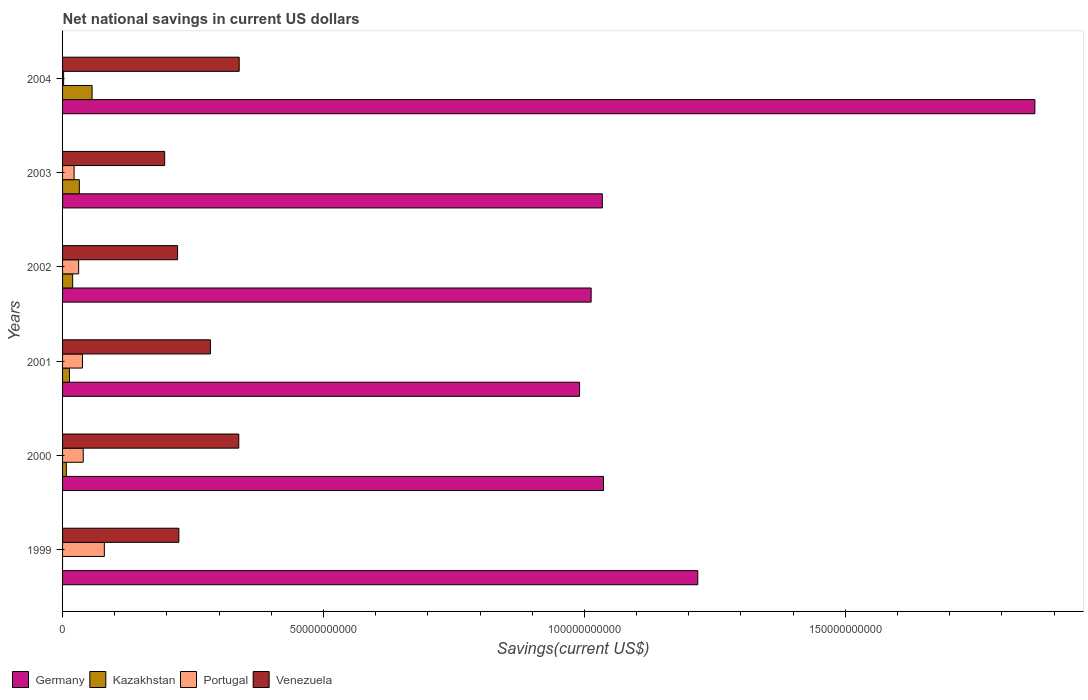Are the number of bars per tick equal to the number of legend labels?
Your response must be concise. No. Are the number of bars on each tick of the Y-axis equal?
Your response must be concise. No. How many bars are there on the 3rd tick from the top?
Your answer should be compact. 4. What is the label of the 1st group of bars from the top?
Make the answer very short. 2004. In how many cases, is the number of bars for a given year not equal to the number of legend labels?
Your answer should be very brief. 1. What is the net national savings in Venezuela in 1999?
Ensure brevity in your answer.  2.23e+1. Across all years, what is the maximum net national savings in Germany?
Your answer should be compact. 1.86e+11. Across all years, what is the minimum net national savings in Germany?
Make the answer very short. 9.91e+1. What is the total net national savings in Venezuela in the graph?
Provide a succinct answer. 1.60e+11. What is the difference between the net national savings in Kazakhstan in 2001 and that in 2003?
Keep it short and to the point. -1.89e+09. What is the difference between the net national savings in Venezuela in 1999 and the net national savings in Germany in 2002?
Ensure brevity in your answer.  -7.90e+1. What is the average net national savings in Kazakhstan per year?
Give a very brief answer. 2.14e+09. In the year 2004, what is the difference between the net national savings in Kazakhstan and net national savings in Venezuela?
Give a very brief answer. -2.82e+1. What is the ratio of the net national savings in Germany in 1999 to that in 2003?
Your answer should be compact. 1.18. What is the difference between the highest and the second highest net national savings in Germany?
Ensure brevity in your answer.  6.46e+1. What is the difference between the highest and the lowest net national savings in Portugal?
Provide a succinct answer. 7.80e+09. Is the sum of the net national savings in Germany in 2000 and 2001 greater than the maximum net national savings in Venezuela across all years?
Offer a terse response. Yes. Is it the case that in every year, the sum of the net national savings in Venezuela and net national savings in Germany is greater than the sum of net national savings in Kazakhstan and net national savings in Portugal?
Your answer should be compact. Yes. How many bars are there?
Keep it short and to the point. 23. Are all the bars in the graph horizontal?
Provide a succinct answer. Yes. How many years are there in the graph?
Ensure brevity in your answer.  6. Where does the legend appear in the graph?
Give a very brief answer. Bottom left. What is the title of the graph?
Make the answer very short. Net national savings in current US dollars. What is the label or title of the X-axis?
Ensure brevity in your answer.  Savings(current US$). What is the label or title of the Y-axis?
Provide a short and direct response. Years. What is the Savings(current US$) of Germany in 1999?
Your answer should be very brief. 1.22e+11. What is the Savings(current US$) in Portugal in 1999?
Your response must be concise. 8.01e+09. What is the Savings(current US$) of Venezuela in 1999?
Offer a very short reply. 2.23e+1. What is the Savings(current US$) in Germany in 2000?
Offer a terse response. 1.04e+11. What is the Savings(current US$) of Kazakhstan in 2000?
Your answer should be compact. 7.24e+08. What is the Savings(current US$) of Portugal in 2000?
Offer a very short reply. 3.96e+09. What is the Savings(current US$) of Venezuela in 2000?
Provide a short and direct response. 3.38e+1. What is the Savings(current US$) of Germany in 2001?
Make the answer very short. 9.91e+1. What is the Savings(current US$) of Kazakhstan in 2001?
Your answer should be compact. 1.33e+09. What is the Savings(current US$) in Portugal in 2001?
Provide a short and direct response. 3.82e+09. What is the Savings(current US$) of Venezuela in 2001?
Offer a very short reply. 2.83e+1. What is the Savings(current US$) of Germany in 2002?
Your response must be concise. 1.01e+11. What is the Savings(current US$) of Kazakhstan in 2002?
Provide a short and direct response. 1.94e+09. What is the Savings(current US$) in Portugal in 2002?
Offer a very short reply. 3.08e+09. What is the Savings(current US$) in Venezuela in 2002?
Your response must be concise. 2.20e+1. What is the Savings(current US$) in Germany in 2003?
Ensure brevity in your answer.  1.03e+11. What is the Savings(current US$) in Kazakhstan in 2003?
Offer a very short reply. 3.22e+09. What is the Savings(current US$) of Portugal in 2003?
Your response must be concise. 2.21e+09. What is the Savings(current US$) of Venezuela in 2003?
Ensure brevity in your answer.  1.96e+1. What is the Savings(current US$) of Germany in 2004?
Offer a terse response. 1.86e+11. What is the Savings(current US$) in Kazakhstan in 2004?
Provide a short and direct response. 5.66e+09. What is the Savings(current US$) in Portugal in 2004?
Offer a very short reply. 2.03e+08. What is the Savings(current US$) in Venezuela in 2004?
Make the answer very short. 3.39e+1. Across all years, what is the maximum Savings(current US$) in Germany?
Offer a very short reply. 1.86e+11. Across all years, what is the maximum Savings(current US$) of Kazakhstan?
Provide a short and direct response. 5.66e+09. Across all years, what is the maximum Savings(current US$) in Portugal?
Provide a succinct answer. 8.01e+09. Across all years, what is the maximum Savings(current US$) in Venezuela?
Keep it short and to the point. 3.39e+1. Across all years, what is the minimum Savings(current US$) in Germany?
Provide a succinct answer. 9.91e+1. Across all years, what is the minimum Savings(current US$) in Portugal?
Offer a terse response. 2.03e+08. Across all years, what is the minimum Savings(current US$) of Venezuela?
Ensure brevity in your answer.  1.96e+1. What is the total Savings(current US$) in Germany in the graph?
Give a very brief answer. 7.16e+11. What is the total Savings(current US$) in Kazakhstan in the graph?
Give a very brief answer. 1.29e+1. What is the total Savings(current US$) of Portugal in the graph?
Provide a short and direct response. 2.13e+1. What is the total Savings(current US$) in Venezuela in the graph?
Your response must be concise. 1.60e+11. What is the difference between the Savings(current US$) in Germany in 1999 and that in 2000?
Your answer should be compact. 1.81e+1. What is the difference between the Savings(current US$) of Portugal in 1999 and that in 2000?
Provide a short and direct response. 4.04e+09. What is the difference between the Savings(current US$) of Venezuela in 1999 and that in 2000?
Keep it short and to the point. -1.15e+1. What is the difference between the Savings(current US$) in Germany in 1999 and that in 2001?
Offer a terse response. 2.27e+1. What is the difference between the Savings(current US$) in Portugal in 1999 and that in 2001?
Offer a very short reply. 4.19e+09. What is the difference between the Savings(current US$) in Venezuela in 1999 and that in 2001?
Your response must be concise. -6.04e+09. What is the difference between the Savings(current US$) of Germany in 1999 and that in 2002?
Your answer should be compact. 2.04e+1. What is the difference between the Savings(current US$) in Portugal in 1999 and that in 2002?
Your response must be concise. 4.92e+09. What is the difference between the Savings(current US$) in Venezuela in 1999 and that in 2002?
Your response must be concise. 2.44e+08. What is the difference between the Savings(current US$) of Germany in 1999 and that in 2003?
Make the answer very short. 1.83e+1. What is the difference between the Savings(current US$) of Portugal in 1999 and that in 2003?
Ensure brevity in your answer.  5.80e+09. What is the difference between the Savings(current US$) in Venezuela in 1999 and that in 2003?
Make the answer very short. 2.72e+09. What is the difference between the Savings(current US$) in Germany in 1999 and that in 2004?
Make the answer very short. -6.46e+1. What is the difference between the Savings(current US$) of Portugal in 1999 and that in 2004?
Your answer should be compact. 7.80e+09. What is the difference between the Savings(current US$) in Venezuela in 1999 and that in 2004?
Your answer should be compact. -1.16e+1. What is the difference between the Savings(current US$) in Germany in 2000 and that in 2001?
Ensure brevity in your answer.  4.59e+09. What is the difference between the Savings(current US$) of Kazakhstan in 2000 and that in 2001?
Your answer should be compact. -6.02e+08. What is the difference between the Savings(current US$) in Portugal in 2000 and that in 2001?
Your answer should be very brief. 1.46e+08. What is the difference between the Savings(current US$) in Venezuela in 2000 and that in 2001?
Provide a succinct answer. 5.44e+09. What is the difference between the Savings(current US$) in Germany in 2000 and that in 2002?
Keep it short and to the point. 2.37e+09. What is the difference between the Savings(current US$) in Kazakhstan in 2000 and that in 2002?
Offer a terse response. -1.21e+09. What is the difference between the Savings(current US$) of Portugal in 2000 and that in 2002?
Give a very brief answer. 8.78e+08. What is the difference between the Savings(current US$) of Venezuela in 2000 and that in 2002?
Your response must be concise. 1.17e+1. What is the difference between the Savings(current US$) in Germany in 2000 and that in 2003?
Keep it short and to the point. 2.28e+08. What is the difference between the Savings(current US$) of Kazakhstan in 2000 and that in 2003?
Your answer should be very brief. -2.49e+09. What is the difference between the Savings(current US$) in Portugal in 2000 and that in 2003?
Offer a terse response. 1.75e+09. What is the difference between the Savings(current US$) of Venezuela in 2000 and that in 2003?
Your answer should be very brief. 1.42e+1. What is the difference between the Savings(current US$) of Germany in 2000 and that in 2004?
Ensure brevity in your answer.  -8.27e+1. What is the difference between the Savings(current US$) in Kazakhstan in 2000 and that in 2004?
Ensure brevity in your answer.  -4.94e+09. What is the difference between the Savings(current US$) of Portugal in 2000 and that in 2004?
Offer a terse response. 3.76e+09. What is the difference between the Savings(current US$) in Venezuela in 2000 and that in 2004?
Provide a succinct answer. -8.18e+07. What is the difference between the Savings(current US$) in Germany in 2001 and that in 2002?
Make the answer very short. -2.22e+09. What is the difference between the Savings(current US$) of Kazakhstan in 2001 and that in 2002?
Offer a terse response. -6.10e+08. What is the difference between the Savings(current US$) of Portugal in 2001 and that in 2002?
Keep it short and to the point. 7.32e+08. What is the difference between the Savings(current US$) of Venezuela in 2001 and that in 2002?
Your answer should be compact. 6.29e+09. What is the difference between the Savings(current US$) of Germany in 2001 and that in 2003?
Your answer should be compact. -4.36e+09. What is the difference between the Savings(current US$) in Kazakhstan in 2001 and that in 2003?
Keep it short and to the point. -1.89e+09. What is the difference between the Savings(current US$) of Portugal in 2001 and that in 2003?
Your answer should be compact. 1.61e+09. What is the difference between the Savings(current US$) of Venezuela in 2001 and that in 2003?
Ensure brevity in your answer.  8.77e+09. What is the difference between the Savings(current US$) in Germany in 2001 and that in 2004?
Your response must be concise. -8.73e+1. What is the difference between the Savings(current US$) in Kazakhstan in 2001 and that in 2004?
Give a very brief answer. -4.33e+09. What is the difference between the Savings(current US$) of Portugal in 2001 and that in 2004?
Give a very brief answer. 3.61e+09. What is the difference between the Savings(current US$) of Venezuela in 2001 and that in 2004?
Keep it short and to the point. -5.52e+09. What is the difference between the Savings(current US$) in Germany in 2002 and that in 2003?
Your answer should be very brief. -2.14e+09. What is the difference between the Savings(current US$) in Kazakhstan in 2002 and that in 2003?
Ensure brevity in your answer.  -1.28e+09. What is the difference between the Savings(current US$) of Portugal in 2002 and that in 2003?
Make the answer very short. 8.75e+08. What is the difference between the Savings(current US$) in Venezuela in 2002 and that in 2003?
Ensure brevity in your answer.  2.48e+09. What is the difference between the Savings(current US$) in Germany in 2002 and that in 2004?
Offer a very short reply. -8.50e+1. What is the difference between the Savings(current US$) of Kazakhstan in 2002 and that in 2004?
Offer a very short reply. -3.72e+09. What is the difference between the Savings(current US$) in Portugal in 2002 and that in 2004?
Your answer should be compact. 2.88e+09. What is the difference between the Savings(current US$) of Venezuela in 2002 and that in 2004?
Make the answer very short. -1.18e+1. What is the difference between the Savings(current US$) in Germany in 2003 and that in 2004?
Make the answer very short. -8.29e+1. What is the difference between the Savings(current US$) in Kazakhstan in 2003 and that in 2004?
Make the answer very short. -2.44e+09. What is the difference between the Savings(current US$) of Portugal in 2003 and that in 2004?
Provide a short and direct response. 2.01e+09. What is the difference between the Savings(current US$) in Venezuela in 2003 and that in 2004?
Offer a terse response. -1.43e+1. What is the difference between the Savings(current US$) of Germany in 1999 and the Savings(current US$) of Kazakhstan in 2000?
Your response must be concise. 1.21e+11. What is the difference between the Savings(current US$) of Germany in 1999 and the Savings(current US$) of Portugal in 2000?
Your response must be concise. 1.18e+11. What is the difference between the Savings(current US$) in Germany in 1999 and the Savings(current US$) in Venezuela in 2000?
Your answer should be compact. 8.80e+1. What is the difference between the Savings(current US$) in Portugal in 1999 and the Savings(current US$) in Venezuela in 2000?
Your answer should be compact. -2.58e+1. What is the difference between the Savings(current US$) of Germany in 1999 and the Savings(current US$) of Kazakhstan in 2001?
Give a very brief answer. 1.20e+11. What is the difference between the Savings(current US$) in Germany in 1999 and the Savings(current US$) in Portugal in 2001?
Offer a very short reply. 1.18e+11. What is the difference between the Savings(current US$) in Germany in 1999 and the Savings(current US$) in Venezuela in 2001?
Keep it short and to the point. 9.34e+1. What is the difference between the Savings(current US$) of Portugal in 1999 and the Savings(current US$) of Venezuela in 2001?
Your answer should be compact. -2.03e+1. What is the difference between the Savings(current US$) of Germany in 1999 and the Savings(current US$) of Kazakhstan in 2002?
Provide a succinct answer. 1.20e+11. What is the difference between the Savings(current US$) in Germany in 1999 and the Savings(current US$) in Portugal in 2002?
Offer a terse response. 1.19e+11. What is the difference between the Savings(current US$) in Germany in 1999 and the Savings(current US$) in Venezuela in 2002?
Provide a succinct answer. 9.97e+1. What is the difference between the Savings(current US$) in Portugal in 1999 and the Savings(current US$) in Venezuela in 2002?
Your answer should be very brief. -1.40e+1. What is the difference between the Savings(current US$) in Germany in 1999 and the Savings(current US$) in Kazakhstan in 2003?
Provide a succinct answer. 1.19e+11. What is the difference between the Savings(current US$) of Germany in 1999 and the Savings(current US$) of Portugal in 2003?
Keep it short and to the point. 1.20e+11. What is the difference between the Savings(current US$) of Germany in 1999 and the Savings(current US$) of Venezuela in 2003?
Give a very brief answer. 1.02e+11. What is the difference between the Savings(current US$) of Portugal in 1999 and the Savings(current US$) of Venezuela in 2003?
Give a very brief answer. -1.16e+1. What is the difference between the Savings(current US$) of Germany in 1999 and the Savings(current US$) of Kazakhstan in 2004?
Your answer should be compact. 1.16e+11. What is the difference between the Savings(current US$) of Germany in 1999 and the Savings(current US$) of Portugal in 2004?
Keep it short and to the point. 1.22e+11. What is the difference between the Savings(current US$) in Germany in 1999 and the Savings(current US$) in Venezuela in 2004?
Make the answer very short. 8.79e+1. What is the difference between the Savings(current US$) of Portugal in 1999 and the Savings(current US$) of Venezuela in 2004?
Keep it short and to the point. -2.58e+1. What is the difference between the Savings(current US$) of Germany in 2000 and the Savings(current US$) of Kazakhstan in 2001?
Offer a terse response. 1.02e+11. What is the difference between the Savings(current US$) of Germany in 2000 and the Savings(current US$) of Portugal in 2001?
Offer a terse response. 9.98e+1. What is the difference between the Savings(current US$) of Germany in 2000 and the Savings(current US$) of Venezuela in 2001?
Provide a short and direct response. 7.53e+1. What is the difference between the Savings(current US$) of Kazakhstan in 2000 and the Savings(current US$) of Portugal in 2001?
Your answer should be very brief. -3.09e+09. What is the difference between the Savings(current US$) in Kazakhstan in 2000 and the Savings(current US$) in Venezuela in 2001?
Provide a short and direct response. -2.76e+1. What is the difference between the Savings(current US$) in Portugal in 2000 and the Savings(current US$) in Venezuela in 2001?
Your answer should be compact. -2.44e+1. What is the difference between the Savings(current US$) in Germany in 2000 and the Savings(current US$) in Kazakhstan in 2002?
Ensure brevity in your answer.  1.02e+11. What is the difference between the Savings(current US$) of Germany in 2000 and the Savings(current US$) of Portugal in 2002?
Make the answer very short. 1.01e+11. What is the difference between the Savings(current US$) in Germany in 2000 and the Savings(current US$) in Venezuela in 2002?
Your response must be concise. 8.16e+1. What is the difference between the Savings(current US$) of Kazakhstan in 2000 and the Savings(current US$) of Portugal in 2002?
Your answer should be very brief. -2.36e+09. What is the difference between the Savings(current US$) in Kazakhstan in 2000 and the Savings(current US$) in Venezuela in 2002?
Offer a very short reply. -2.13e+1. What is the difference between the Savings(current US$) of Portugal in 2000 and the Savings(current US$) of Venezuela in 2002?
Provide a short and direct response. -1.81e+1. What is the difference between the Savings(current US$) of Germany in 2000 and the Savings(current US$) of Kazakhstan in 2003?
Give a very brief answer. 1.00e+11. What is the difference between the Savings(current US$) of Germany in 2000 and the Savings(current US$) of Portugal in 2003?
Make the answer very short. 1.01e+11. What is the difference between the Savings(current US$) in Germany in 2000 and the Savings(current US$) in Venezuela in 2003?
Make the answer very short. 8.41e+1. What is the difference between the Savings(current US$) in Kazakhstan in 2000 and the Savings(current US$) in Portugal in 2003?
Provide a succinct answer. -1.49e+09. What is the difference between the Savings(current US$) of Kazakhstan in 2000 and the Savings(current US$) of Venezuela in 2003?
Provide a short and direct response. -1.88e+1. What is the difference between the Savings(current US$) in Portugal in 2000 and the Savings(current US$) in Venezuela in 2003?
Ensure brevity in your answer.  -1.56e+1. What is the difference between the Savings(current US$) of Germany in 2000 and the Savings(current US$) of Kazakhstan in 2004?
Your answer should be very brief. 9.80e+1. What is the difference between the Savings(current US$) of Germany in 2000 and the Savings(current US$) of Portugal in 2004?
Offer a terse response. 1.03e+11. What is the difference between the Savings(current US$) in Germany in 2000 and the Savings(current US$) in Venezuela in 2004?
Provide a succinct answer. 6.98e+1. What is the difference between the Savings(current US$) in Kazakhstan in 2000 and the Savings(current US$) in Portugal in 2004?
Provide a succinct answer. 5.20e+08. What is the difference between the Savings(current US$) of Kazakhstan in 2000 and the Savings(current US$) of Venezuela in 2004?
Offer a very short reply. -3.31e+1. What is the difference between the Savings(current US$) in Portugal in 2000 and the Savings(current US$) in Venezuela in 2004?
Offer a very short reply. -2.99e+1. What is the difference between the Savings(current US$) of Germany in 2001 and the Savings(current US$) of Kazakhstan in 2002?
Give a very brief answer. 9.71e+1. What is the difference between the Savings(current US$) in Germany in 2001 and the Savings(current US$) in Portugal in 2002?
Provide a short and direct response. 9.60e+1. What is the difference between the Savings(current US$) of Germany in 2001 and the Savings(current US$) of Venezuela in 2002?
Offer a very short reply. 7.70e+1. What is the difference between the Savings(current US$) in Kazakhstan in 2001 and the Savings(current US$) in Portugal in 2002?
Make the answer very short. -1.76e+09. What is the difference between the Savings(current US$) of Kazakhstan in 2001 and the Savings(current US$) of Venezuela in 2002?
Ensure brevity in your answer.  -2.07e+1. What is the difference between the Savings(current US$) of Portugal in 2001 and the Savings(current US$) of Venezuela in 2002?
Provide a short and direct response. -1.82e+1. What is the difference between the Savings(current US$) in Germany in 2001 and the Savings(current US$) in Kazakhstan in 2003?
Your answer should be very brief. 9.59e+1. What is the difference between the Savings(current US$) of Germany in 2001 and the Savings(current US$) of Portugal in 2003?
Offer a very short reply. 9.69e+1. What is the difference between the Savings(current US$) of Germany in 2001 and the Savings(current US$) of Venezuela in 2003?
Ensure brevity in your answer.  7.95e+1. What is the difference between the Savings(current US$) of Kazakhstan in 2001 and the Savings(current US$) of Portugal in 2003?
Provide a succinct answer. -8.84e+08. What is the difference between the Savings(current US$) in Kazakhstan in 2001 and the Savings(current US$) in Venezuela in 2003?
Your answer should be compact. -1.82e+1. What is the difference between the Savings(current US$) of Portugal in 2001 and the Savings(current US$) of Venezuela in 2003?
Offer a very short reply. -1.57e+1. What is the difference between the Savings(current US$) in Germany in 2001 and the Savings(current US$) in Kazakhstan in 2004?
Your answer should be very brief. 9.34e+1. What is the difference between the Savings(current US$) in Germany in 2001 and the Savings(current US$) in Portugal in 2004?
Your answer should be very brief. 9.89e+1. What is the difference between the Savings(current US$) of Germany in 2001 and the Savings(current US$) of Venezuela in 2004?
Offer a very short reply. 6.52e+1. What is the difference between the Savings(current US$) of Kazakhstan in 2001 and the Savings(current US$) of Portugal in 2004?
Provide a short and direct response. 1.12e+09. What is the difference between the Savings(current US$) in Kazakhstan in 2001 and the Savings(current US$) in Venezuela in 2004?
Offer a terse response. -3.25e+1. What is the difference between the Savings(current US$) of Portugal in 2001 and the Savings(current US$) of Venezuela in 2004?
Ensure brevity in your answer.  -3.00e+1. What is the difference between the Savings(current US$) in Germany in 2002 and the Savings(current US$) in Kazakhstan in 2003?
Keep it short and to the point. 9.81e+1. What is the difference between the Savings(current US$) of Germany in 2002 and the Savings(current US$) of Portugal in 2003?
Offer a terse response. 9.91e+1. What is the difference between the Savings(current US$) in Germany in 2002 and the Savings(current US$) in Venezuela in 2003?
Make the answer very short. 8.17e+1. What is the difference between the Savings(current US$) of Kazakhstan in 2002 and the Savings(current US$) of Portugal in 2003?
Make the answer very short. -2.74e+08. What is the difference between the Savings(current US$) in Kazakhstan in 2002 and the Savings(current US$) in Venezuela in 2003?
Offer a very short reply. -1.76e+1. What is the difference between the Savings(current US$) in Portugal in 2002 and the Savings(current US$) in Venezuela in 2003?
Provide a short and direct response. -1.65e+1. What is the difference between the Savings(current US$) in Germany in 2002 and the Savings(current US$) in Kazakhstan in 2004?
Your answer should be very brief. 9.56e+1. What is the difference between the Savings(current US$) of Germany in 2002 and the Savings(current US$) of Portugal in 2004?
Keep it short and to the point. 1.01e+11. What is the difference between the Savings(current US$) in Germany in 2002 and the Savings(current US$) in Venezuela in 2004?
Provide a short and direct response. 6.74e+1. What is the difference between the Savings(current US$) of Kazakhstan in 2002 and the Savings(current US$) of Portugal in 2004?
Provide a short and direct response. 1.73e+09. What is the difference between the Savings(current US$) in Kazakhstan in 2002 and the Savings(current US$) in Venezuela in 2004?
Provide a succinct answer. -3.19e+1. What is the difference between the Savings(current US$) of Portugal in 2002 and the Savings(current US$) of Venezuela in 2004?
Give a very brief answer. -3.08e+1. What is the difference between the Savings(current US$) of Germany in 2003 and the Savings(current US$) of Kazakhstan in 2004?
Offer a very short reply. 9.78e+1. What is the difference between the Savings(current US$) of Germany in 2003 and the Savings(current US$) of Portugal in 2004?
Give a very brief answer. 1.03e+11. What is the difference between the Savings(current US$) of Germany in 2003 and the Savings(current US$) of Venezuela in 2004?
Offer a terse response. 6.96e+1. What is the difference between the Savings(current US$) of Kazakhstan in 2003 and the Savings(current US$) of Portugal in 2004?
Offer a terse response. 3.01e+09. What is the difference between the Savings(current US$) in Kazakhstan in 2003 and the Savings(current US$) in Venezuela in 2004?
Make the answer very short. -3.06e+1. What is the difference between the Savings(current US$) in Portugal in 2003 and the Savings(current US$) in Venezuela in 2004?
Provide a succinct answer. -3.16e+1. What is the average Savings(current US$) in Germany per year?
Your answer should be compact. 1.19e+11. What is the average Savings(current US$) of Kazakhstan per year?
Your response must be concise. 2.14e+09. What is the average Savings(current US$) of Portugal per year?
Provide a succinct answer. 3.55e+09. What is the average Savings(current US$) in Venezuela per year?
Your answer should be very brief. 2.66e+1. In the year 1999, what is the difference between the Savings(current US$) in Germany and Savings(current US$) in Portugal?
Keep it short and to the point. 1.14e+11. In the year 1999, what is the difference between the Savings(current US$) in Germany and Savings(current US$) in Venezuela?
Keep it short and to the point. 9.94e+1. In the year 1999, what is the difference between the Savings(current US$) of Portugal and Savings(current US$) of Venezuela?
Your response must be concise. -1.43e+1. In the year 2000, what is the difference between the Savings(current US$) in Germany and Savings(current US$) in Kazakhstan?
Offer a terse response. 1.03e+11. In the year 2000, what is the difference between the Savings(current US$) in Germany and Savings(current US$) in Portugal?
Your answer should be compact. 9.97e+1. In the year 2000, what is the difference between the Savings(current US$) in Germany and Savings(current US$) in Venezuela?
Provide a succinct answer. 6.99e+1. In the year 2000, what is the difference between the Savings(current US$) of Kazakhstan and Savings(current US$) of Portugal?
Your response must be concise. -3.24e+09. In the year 2000, what is the difference between the Savings(current US$) of Kazakhstan and Savings(current US$) of Venezuela?
Your response must be concise. -3.30e+1. In the year 2000, what is the difference between the Savings(current US$) in Portugal and Savings(current US$) in Venezuela?
Give a very brief answer. -2.98e+1. In the year 2001, what is the difference between the Savings(current US$) in Germany and Savings(current US$) in Kazakhstan?
Your answer should be compact. 9.77e+1. In the year 2001, what is the difference between the Savings(current US$) of Germany and Savings(current US$) of Portugal?
Provide a succinct answer. 9.53e+1. In the year 2001, what is the difference between the Savings(current US$) in Germany and Savings(current US$) in Venezuela?
Offer a terse response. 7.07e+1. In the year 2001, what is the difference between the Savings(current US$) in Kazakhstan and Savings(current US$) in Portugal?
Your answer should be very brief. -2.49e+09. In the year 2001, what is the difference between the Savings(current US$) in Kazakhstan and Savings(current US$) in Venezuela?
Your answer should be compact. -2.70e+1. In the year 2001, what is the difference between the Savings(current US$) in Portugal and Savings(current US$) in Venezuela?
Ensure brevity in your answer.  -2.45e+1. In the year 2002, what is the difference between the Savings(current US$) of Germany and Savings(current US$) of Kazakhstan?
Offer a very short reply. 9.94e+1. In the year 2002, what is the difference between the Savings(current US$) in Germany and Savings(current US$) in Portugal?
Offer a terse response. 9.82e+1. In the year 2002, what is the difference between the Savings(current US$) in Germany and Savings(current US$) in Venezuela?
Your answer should be compact. 7.93e+1. In the year 2002, what is the difference between the Savings(current US$) in Kazakhstan and Savings(current US$) in Portugal?
Keep it short and to the point. -1.15e+09. In the year 2002, what is the difference between the Savings(current US$) in Kazakhstan and Savings(current US$) in Venezuela?
Give a very brief answer. -2.01e+1. In the year 2002, what is the difference between the Savings(current US$) of Portugal and Savings(current US$) of Venezuela?
Offer a very short reply. -1.90e+1. In the year 2003, what is the difference between the Savings(current US$) in Germany and Savings(current US$) in Kazakhstan?
Ensure brevity in your answer.  1.00e+11. In the year 2003, what is the difference between the Savings(current US$) in Germany and Savings(current US$) in Portugal?
Your answer should be very brief. 1.01e+11. In the year 2003, what is the difference between the Savings(current US$) in Germany and Savings(current US$) in Venezuela?
Your answer should be very brief. 8.39e+1. In the year 2003, what is the difference between the Savings(current US$) in Kazakhstan and Savings(current US$) in Portugal?
Provide a short and direct response. 1.01e+09. In the year 2003, what is the difference between the Savings(current US$) in Kazakhstan and Savings(current US$) in Venezuela?
Offer a very short reply. -1.63e+1. In the year 2003, what is the difference between the Savings(current US$) of Portugal and Savings(current US$) of Venezuela?
Provide a short and direct response. -1.74e+1. In the year 2004, what is the difference between the Savings(current US$) in Germany and Savings(current US$) in Kazakhstan?
Keep it short and to the point. 1.81e+11. In the year 2004, what is the difference between the Savings(current US$) of Germany and Savings(current US$) of Portugal?
Provide a succinct answer. 1.86e+11. In the year 2004, what is the difference between the Savings(current US$) in Germany and Savings(current US$) in Venezuela?
Make the answer very short. 1.52e+11. In the year 2004, what is the difference between the Savings(current US$) of Kazakhstan and Savings(current US$) of Portugal?
Make the answer very short. 5.46e+09. In the year 2004, what is the difference between the Savings(current US$) in Kazakhstan and Savings(current US$) in Venezuela?
Make the answer very short. -2.82e+1. In the year 2004, what is the difference between the Savings(current US$) of Portugal and Savings(current US$) of Venezuela?
Ensure brevity in your answer.  -3.36e+1. What is the ratio of the Savings(current US$) of Germany in 1999 to that in 2000?
Offer a very short reply. 1.17. What is the ratio of the Savings(current US$) in Portugal in 1999 to that in 2000?
Your answer should be very brief. 2.02. What is the ratio of the Savings(current US$) of Venezuela in 1999 to that in 2000?
Your answer should be very brief. 0.66. What is the ratio of the Savings(current US$) in Germany in 1999 to that in 2001?
Provide a succinct answer. 1.23. What is the ratio of the Savings(current US$) in Portugal in 1999 to that in 2001?
Provide a succinct answer. 2.1. What is the ratio of the Savings(current US$) in Venezuela in 1999 to that in 2001?
Your response must be concise. 0.79. What is the ratio of the Savings(current US$) in Germany in 1999 to that in 2002?
Make the answer very short. 1.2. What is the ratio of the Savings(current US$) in Portugal in 1999 to that in 2002?
Ensure brevity in your answer.  2.6. What is the ratio of the Savings(current US$) in Venezuela in 1999 to that in 2002?
Offer a very short reply. 1.01. What is the ratio of the Savings(current US$) of Germany in 1999 to that in 2003?
Provide a short and direct response. 1.18. What is the ratio of the Savings(current US$) of Portugal in 1999 to that in 2003?
Ensure brevity in your answer.  3.62. What is the ratio of the Savings(current US$) of Venezuela in 1999 to that in 2003?
Your answer should be very brief. 1.14. What is the ratio of the Savings(current US$) in Germany in 1999 to that in 2004?
Make the answer very short. 0.65. What is the ratio of the Savings(current US$) of Portugal in 1999 to that in 2004?
Offer a very short reply. 39.36. What is the ratio of the Savings(current US$) in Venezuela in 1999 to that in 2004?
Make the answer very short. 0.66. What is the ratio of the Savings(current US$) of Germany in 2000 to that in 2001?
Your answer should be compact. 1.05. What is the ratio of the Savings(current US$) in Kazakhstan in 2000 to that in 2001?
Offer a terse response. 0.55. What is the ratio of the Savings(current US$) of Portugal in 2000 to that in 2001?
Make the answer very short. 1.04. What is the ratio of the Savings(current US$) in Venezuela in 2000 to that in 2001?
Your response must be concise. 1.19. What is the ratio of the Savings(current US$) in Germany in 2000 to that in 2002?
Keep it short and to the point. 1.02. What is the ratio of the Savings(current US$) of Kazakhstan in 2000 to that in 2002?
Your answer should be very brief. 0.37. What is the ratio of the Savings(current US$) of Portugal in 2000 to that in 2002?
Ensure brevity in your answer.  1.28. What is the ratio of the Savings(current US$) in Venezuela in 2000 to that in 2002?
Offer a very short reply. 1.53. What is the ratio of the Savings(current US$) of Kazakhstan in 2000 to that in 2003?
Provide a succinct answer. 0.23. What is the ratio of the Savings(current US$) in Portugal in 2000 to that in 2003?
Give a very brief answer. 1.79. What is the ratio of the Savings(current US$) of Venezuela in 2000 to that in 2003?
Offer a very short reply. 1.73. What is the ratio of the Savings(current US$) in Germany in 2000 to that in 2004?
Offer a terse response. 0.56. What is the ratio of the Savings(current US$) of Kazakhstan in 2000 to that in 2004?
Your answer should be compact. 0.13. What is the ratio of the Savings(current US$) in Portugal in 2000 to that in 2004?
Offer a terse response. 19.48. What is the ratio of the Savings(current US$) in Venezuela in 2000 to that in 2004?
Give a very brief answer. 1. What is the ratio of the Savings(current US$) in Germany in 2001 to that in 2002?
Keep it short and to the point. 0.98. What is the ratio of the Savings(current US$) in Kazakhstan in 2001 to that in 2002?
Ensure brevity in your answer.  0.69. What is the ratio of the Savings(current US$) of Portugal in 2001 to that in 2002?
Make the answer very short. 1.24. What is the ratio of the Savings(current US$) in Venezuela in 2001 to that in 2002?
Ensure brevity in your answer.  1.29. What is the ratio of the Savings(current US$) of Germany in 2001 to that in 2003?
Make the answer very short. 0.96. What is the ratio of the Savings(current US$) in Kazakhstan in 2001 to that in 2003?
Offer a very short reply. 0.41. What is the ratio of the Savings(current US$) in Portugal in 2001 to that in 2003?
Provide a succinct answer. 1.73. What is the ratio of the Savings(current US$) in Venezuela in 2001 to that in 2003?
Your answer should be compact. 1.45. What is the ratio of the Savings(current US$) of Germany in 2001 to that in 2004?
Your answer should be compact. 0.53. What is the ratio of the Savings(current US$) of Kazakhstan in 2001 to that in 2004?
Keep it short and to the point. 0.23. What is the ratio of the Savings(current US$) in Portugal in 2001 to that in 2004?
Ensure brevity in your answer.  18.76. What is the ratio of the Savings(current US$) in Venezuela in 2001 to that in 2004?
Ensure brevity in your answer.  0.84. What is the ratio of the Savings(current US$) in Germany in 2002 to that in 2003?
Provide a succinct answer. 0.98. What is the ratio of the Savings(current US$) of Kazakhstan in 2002 to that in 2003?
Offer a terse response. 0.6. What is the ratio of the Savings(current US$) in Portugal in 2002 to that in 2003?
Keep it short and to the point. 1.4. What is the ratio of the Savings(current US$) in Venezuela in 2002 to that in 2003?
Provide a short and direct response. 1.13. What is the ratio of the Savings(current US$) of Germany in 2002 to that in 2004?
Make the answer very short. 0.54. What is the ratio of the Savings(current US$) in Kazakhstan in 2002 to that in 2004?
Offer a very short reply. 0.34. What is the ratio of the Savings(current US$) in Portugal in 2002 to that in 2004?
Provide a short and direct response. 15.17. What is the ratio of the Savings(current US$) in Venezuela in 2002 to that in 2004?
Keep it short and to the point. 0.65. What is the ratio of the Savings(current US$) of Germany in 2003 to that in 2004?
Ensure brevity in your answer.  0.56. What is the ratio of the Savings(current US$) of Kazakhstan in 2003 to that in 2004?
Offer a terse response. 0.57. What is the ratio of the Savings(current US$) in Portugal in 2003 to that in 2004?
Keep it short and to the point. 10.87. What is the ratio of the Savings(current US$) in Venezuela in 2003 to that in 2004?
Provide a succinct answer. 0.58. What is the difference between the highest and the second highest Savings(current US$) of Germany?
Make the answer very short. 6.46e+1. What is the difference between the highest and the second highest Savings(current US$) of Kazakhstan?
Your response must be concise. 2.44e+09. What is the difference between the highest and the second highest Savings(current US$) in Portugal?
Provide a succinct answer. 4.04e+09. What is the difference between the highest and the second highest Savings(current US$) in Venezuela?
Keep it short and to the point. 8.18e+07. What is the difference between the highest and the lowest Savings(current US$) in Germany?
Keep it short and to the point. 8.73e+1. What is the difference between the highest and the lowest Savings(current US$) in Kazakhstan?
Provide a short and direct response. 5.66e+09. What is the difference between the highest and the lowest Savings(current US$) of Portugal?
Offer a very short reply. 7.80e+09. What is the difference between the highest and the lowest Savings(current US$) of Venezuela?
Keep it short and to the point. 1.43e+1. 